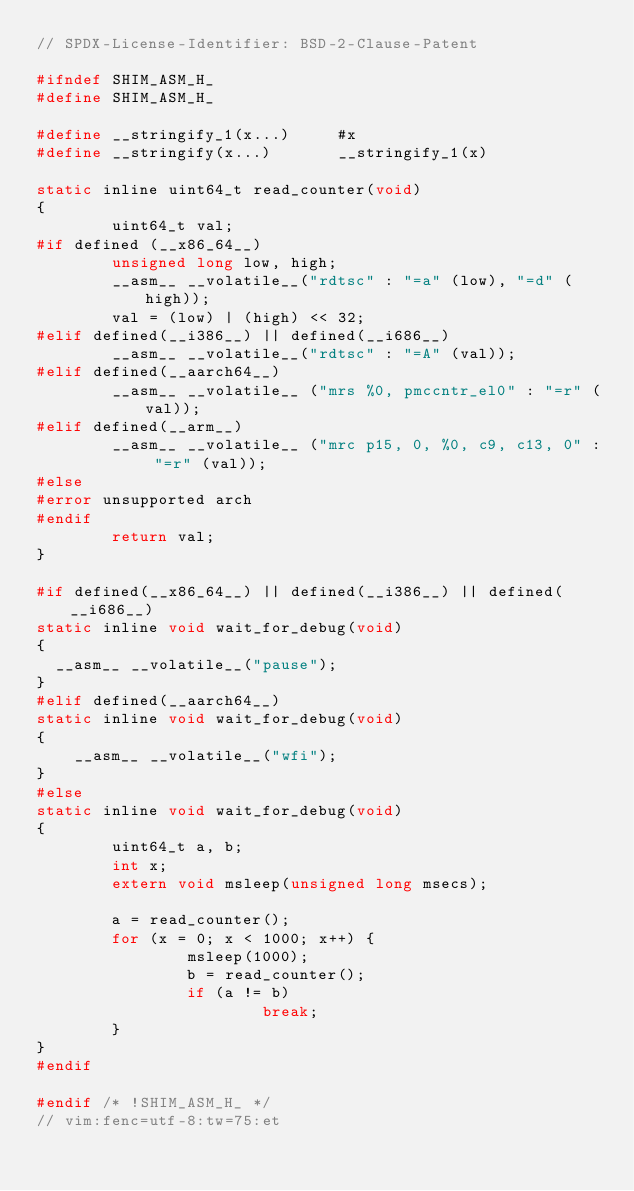<code> <loc_0><loc_0><loc_500><loc_500><_C_>// SPDX-License-Identifier: BSD-2-Clause-Patent

#ifndef SHIM_ASM_H_
#define SHIM_ASM_H_

#define __stringify_1(x...)     #x
#define __stringify(x...)       __stringify_1(x)

static inline uint64_t read_counter(void)
{
        uint64_t val;
#if defined (__x86_64__)
        unsigned long low, high;
        __asm__ __volatile__("rdtsc" : "=a" (low), "=d" (high));
        val = (low) | (high) << 32;
#elif defined(__i386__) || defined(__i686__)
        __asm__ __volatile__("rdtsc" : "=A" (val));
#elif defined(__aarch64__)
        __asm__ __volatile__ ("mrs %0, pmccntr_el0" : "=r" (val));
#elif defined(__arm__)
        __asm__ __volatile__ ("mrc p15, 0, %0, c9, c13, 0" : "=r" (val));
#else
#error unsupported arch
#endif
        return val;
}

#if defined(__x86_64__) || defined(__i386__) || defined(__i686__)
static inline void wait_for_debug(void)
{
	__asm__ __volatile__("pause");
}
#elif defined(__aarch64__)
static inline void wait_for_debug(void)
{
		__asm__ __volatile__("wfi");
}
#else
static inline void wait_for_debug(void)
{
        uint64_t a, b;
        int x;
        extern void msleep(unsigned long msecs);

        a = read_counter();
        for (x = 0; x < 1000; x++) {
                msleep(1000);
                b = read_counter();
                if (a != b)
                        break;
        }
}
#endif

#endif /* !SHIM_ASM_H_ */
// vim:fenc=utf-8:tw=75:et
</code> 